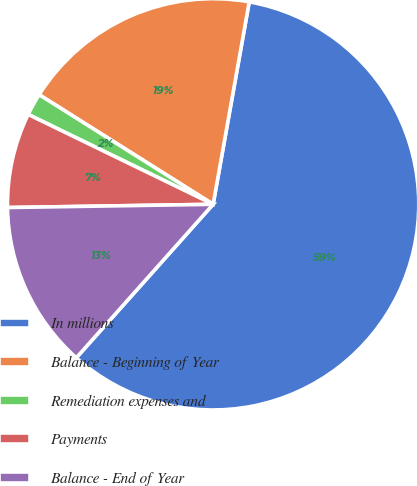Convert chart. <chart><loc_0><loc_0><loc_500><loc_500><pie_chart><fcel>In millions<fcel>Balance - Beginning of Year<fcel>Remediation expenses and<fcel>Payments<fcel>Balance - End of Year<nl><fcel>58.78%<fcel>18.86%<fcel>1.75%<fcel>7.45%<fcel>13.16%<nl></chart> 